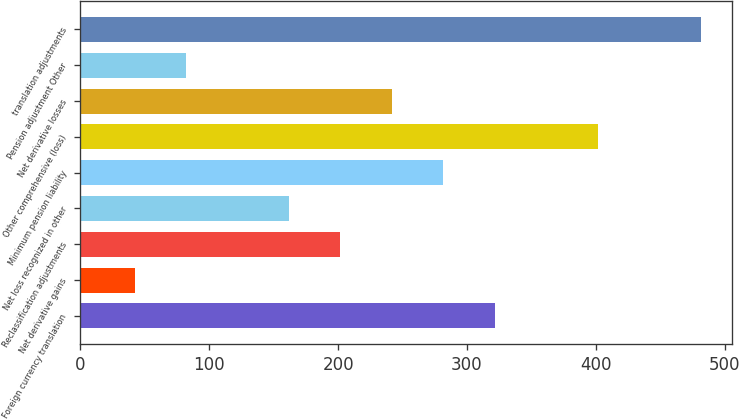<chart> <loc_0><loc_0><loc_500><loc_500><bar_chart><fcel>Foreign currency translation<fcel>Net derivative gains<fcel>Reclassification adjustments<fcel>Net loss recognized in other<fcel>Minimum pension liability<fcel>Other comprehensive (loss)<fcel>Net derivative losses<fcel>Pension adjustment Other<fcel>translation adjustments<nl><fcel>321.62<fcel>42.04<fcel>201.8<fcel>161.86<fcel>281.68<fcel>401.5<fcel>241.74<fcel>81.98<fcel>481.38<nl></chart> 